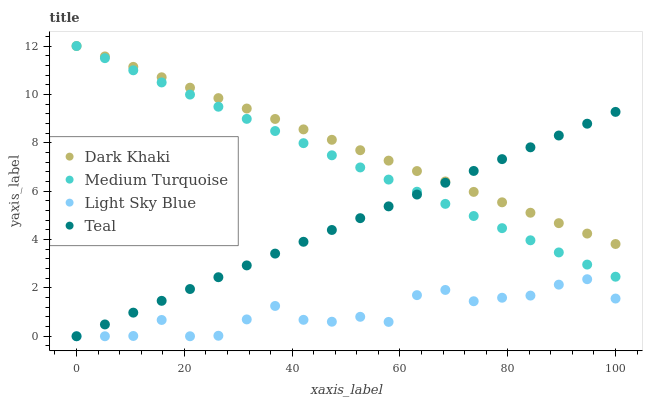Does Light Sky Blue have the minimum area under the curve?
Answer yes or no. Yes. Does Dark Khaki have the maximum area under the curve?
Answer yes or no. Yes. Does Teal have the minimum area under the curve?
Answer yes or no. No. Does Teal have the maximum area under the curve?
Answer yes or no. No. Is Teal the smoothest?
Answer yes or no. Yes. Is Light Sky Blue the roughest?
Answer yes or no. Yes. Is Light Sky Blue the smoothest?
Answer yes or no. No. Is Teal the roughest?
Answer yes or no. No. Does Light Sky Blue have the lowest value?
Answer yes or no. Yes. Does Medium Turquoise have the lowest value?
Answer yes or no. No. Does Medium Turquoise have the highest value?
Answer yes or no. Yes. Does Teal have the highest value?
Answer yes or no. No. Is Light Sky Blue less than Medium Turquoise?
Answer yes or no. Yes. Is Medium Turquoise greater than Light Sky Blue?
Answer yes or no. Yes. Does Dark Khaki intersect Teal?
Answer yes or no. Yes. Is Dark Khaki less than Teal?
Answer yes or no. No. Is Dark Khaki greater than Teal?
Answer yes or no. No. Does Light Sky Blue intersect Medium Turquoise?
Answer yes or no. No. 